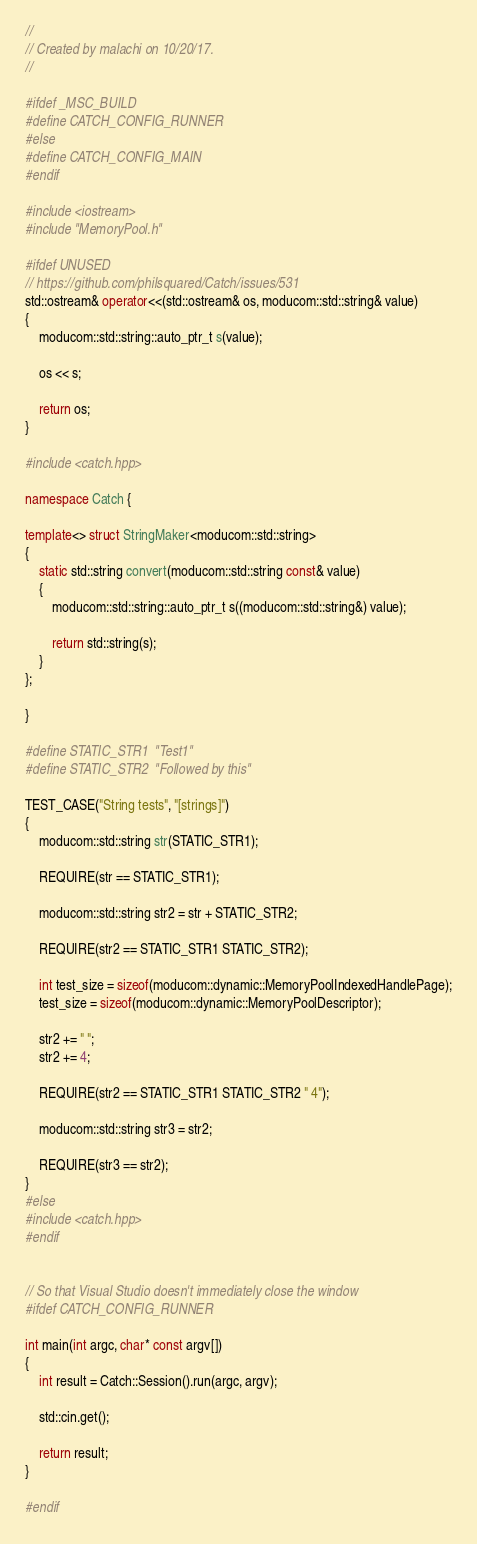<code> <loc_0><loc_0><loc_500><loc_500><_C++_>//
// Created by malachi on 10/20/17.
//

#ifdef _MSC_BUILD
#define CATCH_CONFIG_RUNNER
#else
#define CATCH_CONFIG_MAIN
#endif

#include <iostream>
#include "MemoryPool.h"

#ifdef UNUSED
// https://github.com/philsquared/Catch/issues/531
std::ostream& operator<<(std::ostream& os, moducom::std::string& value)
{
    moducom::std::string::auto_ptr_t s(value);

    os << s;

    return os;
}

#include <catch.hpp>

namespace Catch {

template<> struct StringMaker<moducom::std::string>
{
    static std::string convert(moducom::std::string const& value)
    {
        moducom::std::string::auto_ptr_t s((moducom::std::string&) value);
        
        return std::string(s);
    }
};

}

#define STATIC_STR1  "Test1"
#define STATIC_STR2  "Followed by this"

TEST_CASE("String tests", "[strings]")
{
    moducom::std::string str(STATIC_STR1);

    REQUIRE(str == STATIC_STR1);

    moducom::std::string str2 = str + STATIC_STR2;

    REQUIRE(str2 == STATIC_STR1 STATIC_STR2);

    int test_size = sizeof(moducom::dynamic::MemoryPoolIndexedHandlePage);
    test_size = sizeof(moducom::dynamic::MemoryPoolDescriptor);

    str2 += " ";
    str2 += 4;

    REQUIRE(str2 == STATIC_STR1 STATIC_STR2 " 4");

    moducom::std::string str3 = str2;

    REQUIRE(str3 == str2);
}
#else
#include <catch.hpp>
#endif


// So that Visual Studio doesn't immediately close the window
#ifdef CATCH_CONFIG_RUNNER

int main(int argc, char* const argv[])
{
    int result = Catch::Session().run(argc, argv);

    std::cin.get();

    return result;
}

#endif</code> 